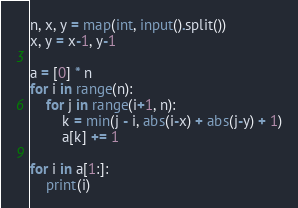<code> <loc_0><loc_0><loc_500><loc_500><_Python_>n, x, y = map(int, input().split())
x, y = x-1, y-1

a = [0] * n
for i in range(n):
    for j in range(i+1, n):
        k = min(j - i, abs(i-x) + abs(j-y) + 1)
        a[k] += 1

for i in a[1:]:
    print(i)</code> 